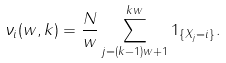<formula> <loc_0><loc_0><loc_500><loc_500>\nu _ { i } ( w , k ) = \frac { N } { w } \sum _ { j = ( k - 1 ) w + 1 } ^ { k w } 1 _ { \{ X _ { j } = i \} } .</formula> 